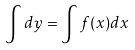<formula> <loc_0><loc_0><loc_500><loc_500>\int d y = \int f ( x ) d x</formula> 